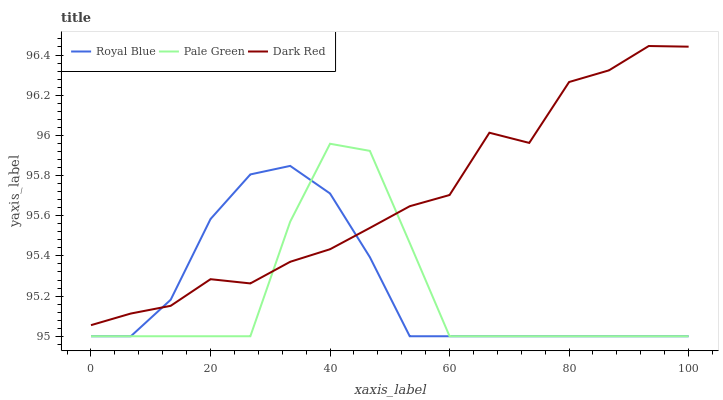Does Pale Green have the minimum area under the curve?
Answer yes or no. Yes. Does Dark Red have the maximum area under the curve?
Answer yes or no. Yes. Does Dark Red have the minimum area under the curve?
Answer yes or no. No. Does Pale Green have the maximum area under the curve?
Answer yes or no. No. Is Royal Blue the smoothest?
Answer yes or no. Yes. Is Pale Green the roughest?
Answer yes or no. Yes. Is Dark Red the smoothest?
Answer yes or no. No. Is Dark Red the roughest?
Answer yes or no. No. Does Dark Red have the lowest value?
Answer yes or no. No. Does Pale Green have the highest value?
Answer yes or no. No. 